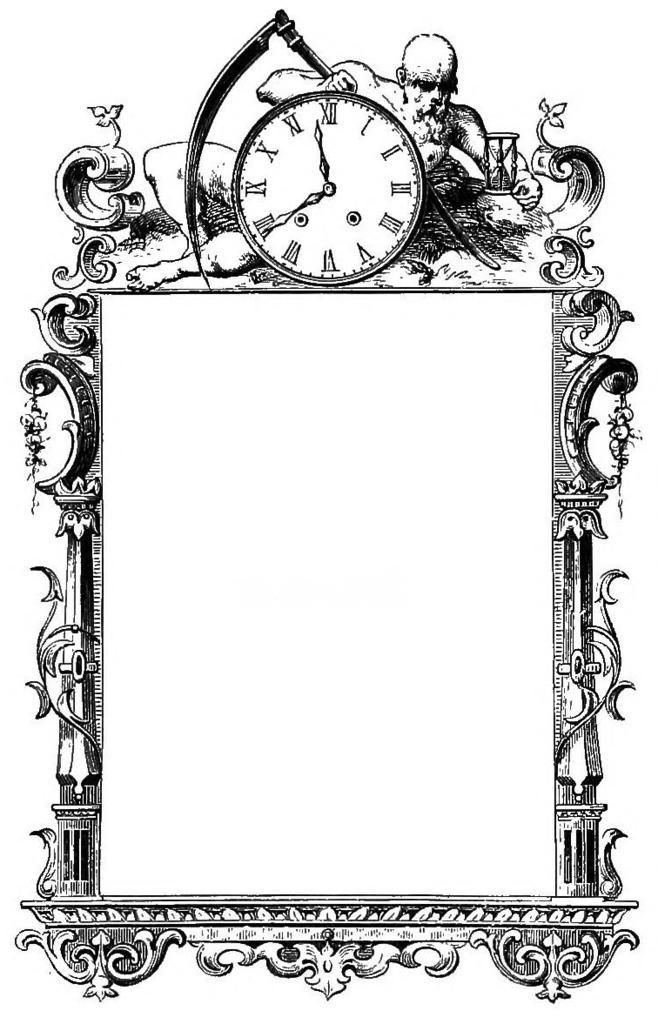How would you summarize this image in a sentence or two? This is a black and white picture. We can see a frame with a clock on that. 